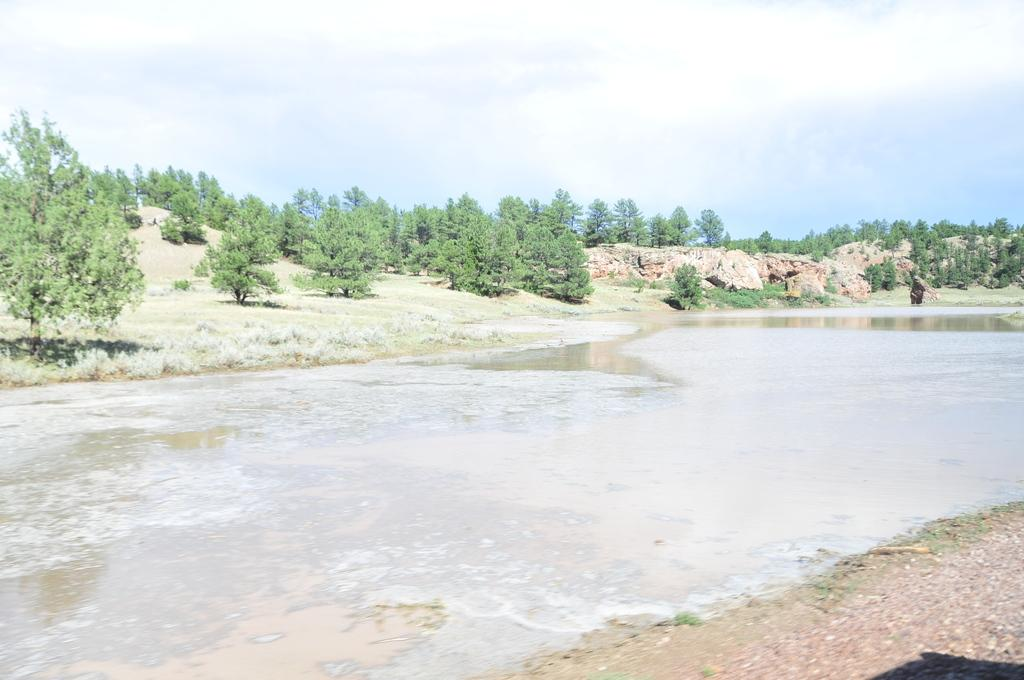What type of vegetation can be seen in the image? There is a group of trees and plants in the image. What is visible in the foreground of the image? Water and rocks are visible in the foreground of the image. What can be seen at the top of the image? The sky is visible at the top of the image. How many cakes are being served for lunch in the image? There are no cakes or references to lunch in the image; it features a natural scene with trees, plants, water, rocks, and the sky. 